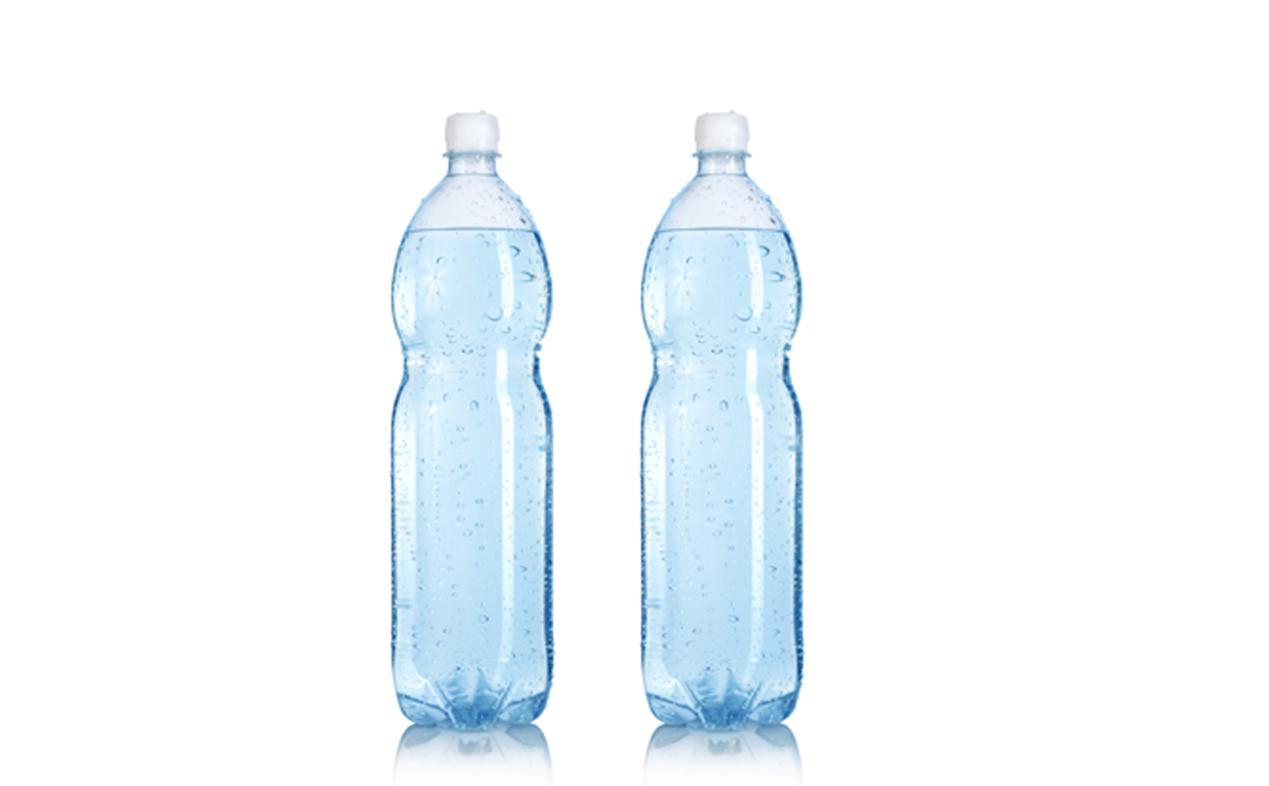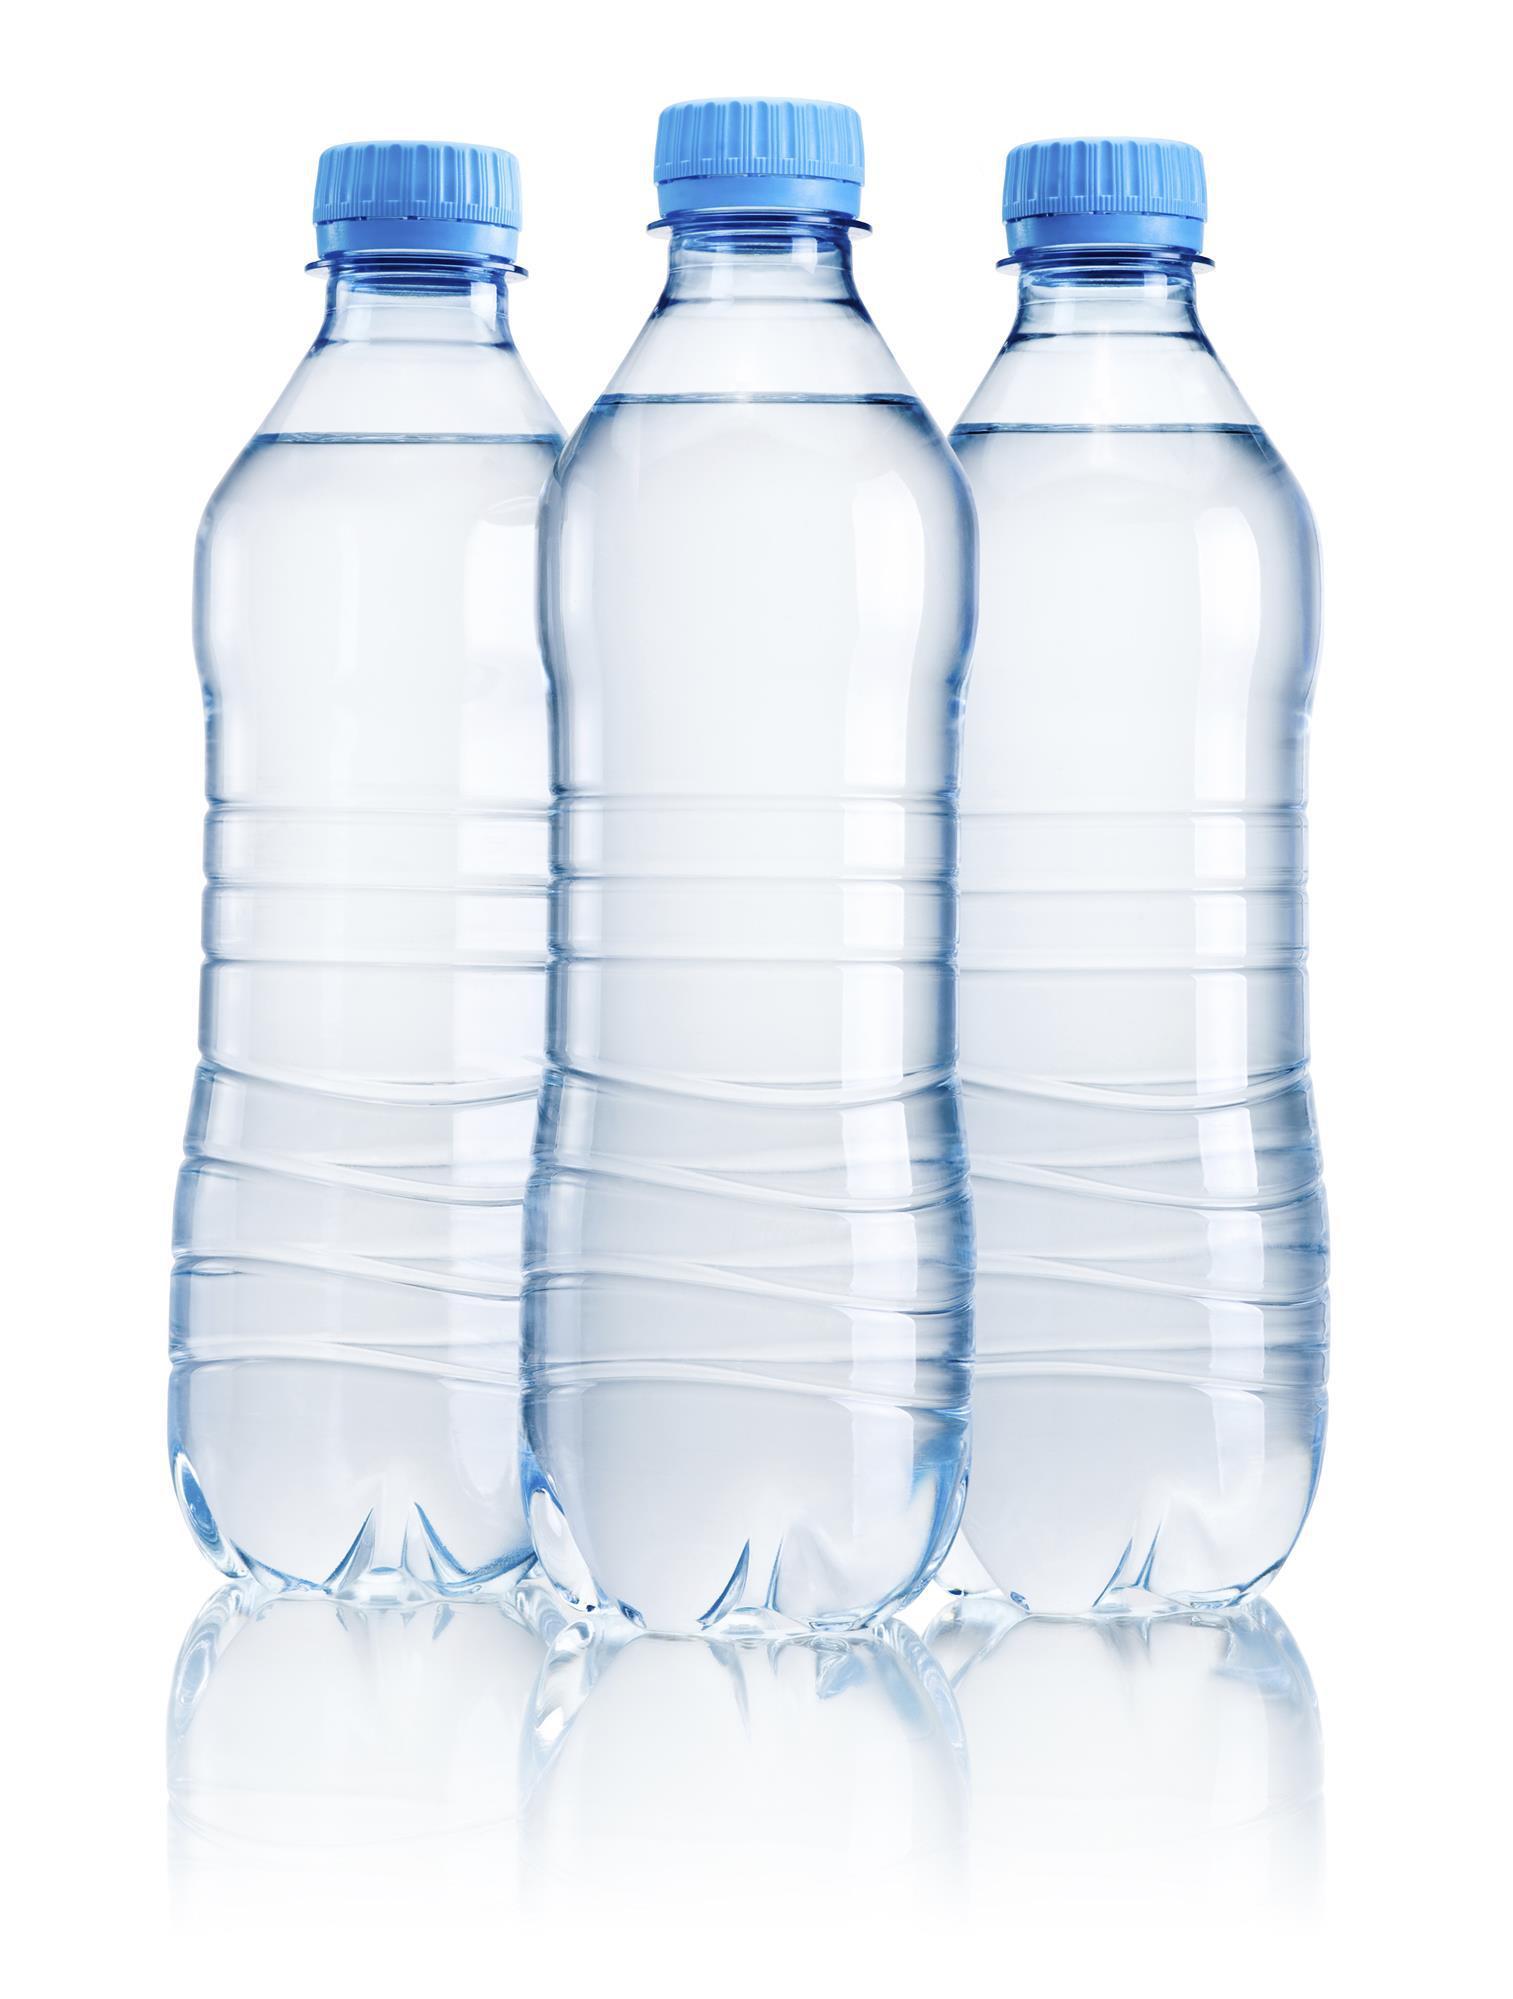The first image is the image on the left, the second image is the image on the right. For the images displayed, is the sentence "There are five bottles in total." factually correct? Answer yes or no. Yes. The first image is the image on the left, the second image is the image on the right. Examine the images to the left and right. Is the description "An image shows exactly two lidded, unlabeled water bottles of the same size and shape, displayed level and side-by-side." accurate? Answer yes or no. Yes. 